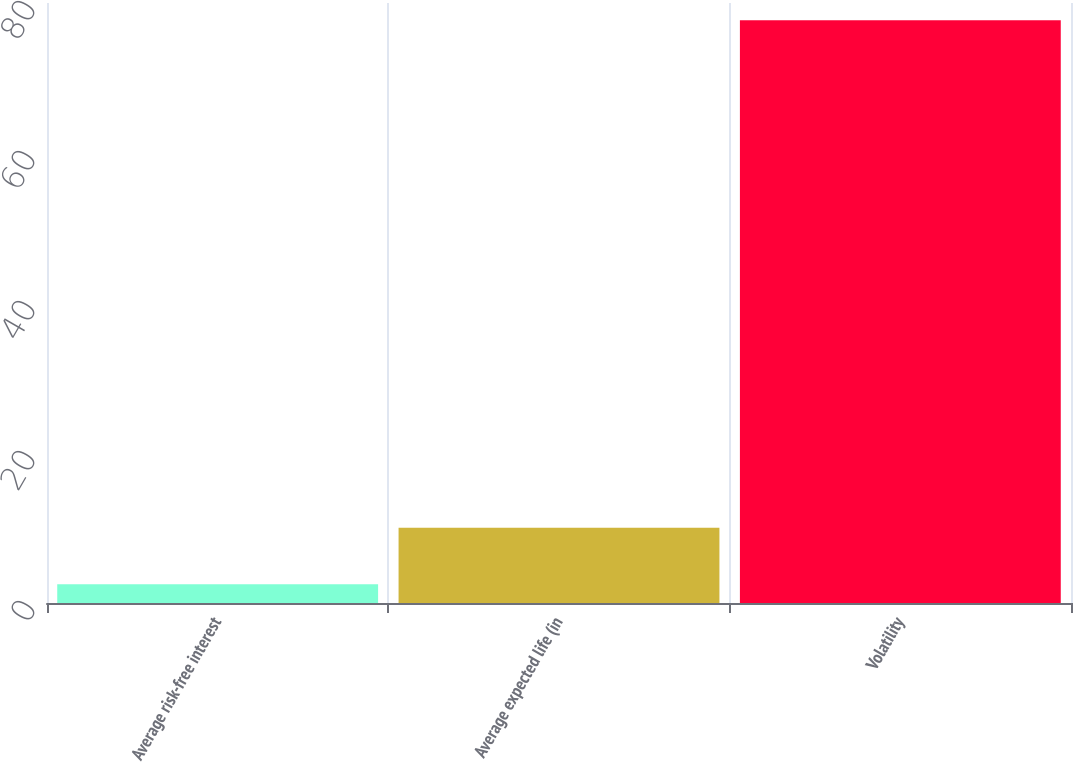<chart> <loc_0><loc_0><loc_500><loc_500><bar_chart><fcel>Average risk-free interest<fcel>Average expected life (in<fcel>Volatility<nl><fcel>2.5<fcel>10.02<fcel>77.7<nl></chart> 